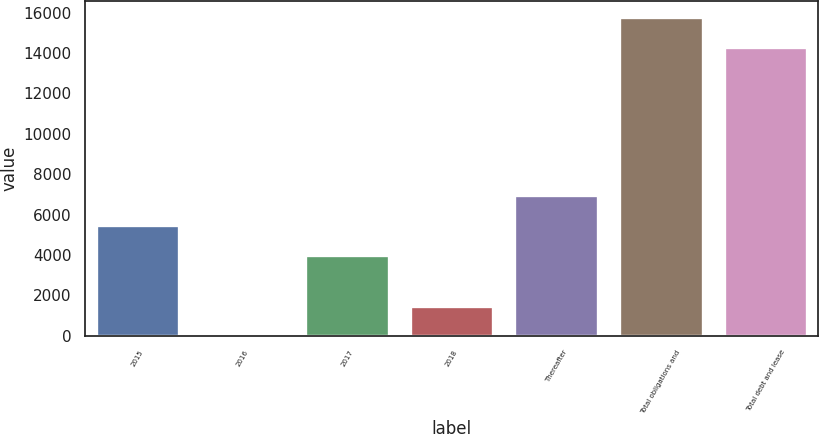<chart> <loc_0><loc_0><loc_500><loc_500><bar_chart><fcel>2015<fcel>2016<fcel>2017<fcel>2018<fcel>Thereafter<fcel>Total obligations and<fcel>Total debt and lease<nl><fcel>5486.7<fcel>11<fcel>4008<fcel>1489.7<fcel>6965.4<fcel>15788.7<fcel>14310<nl></chart> 